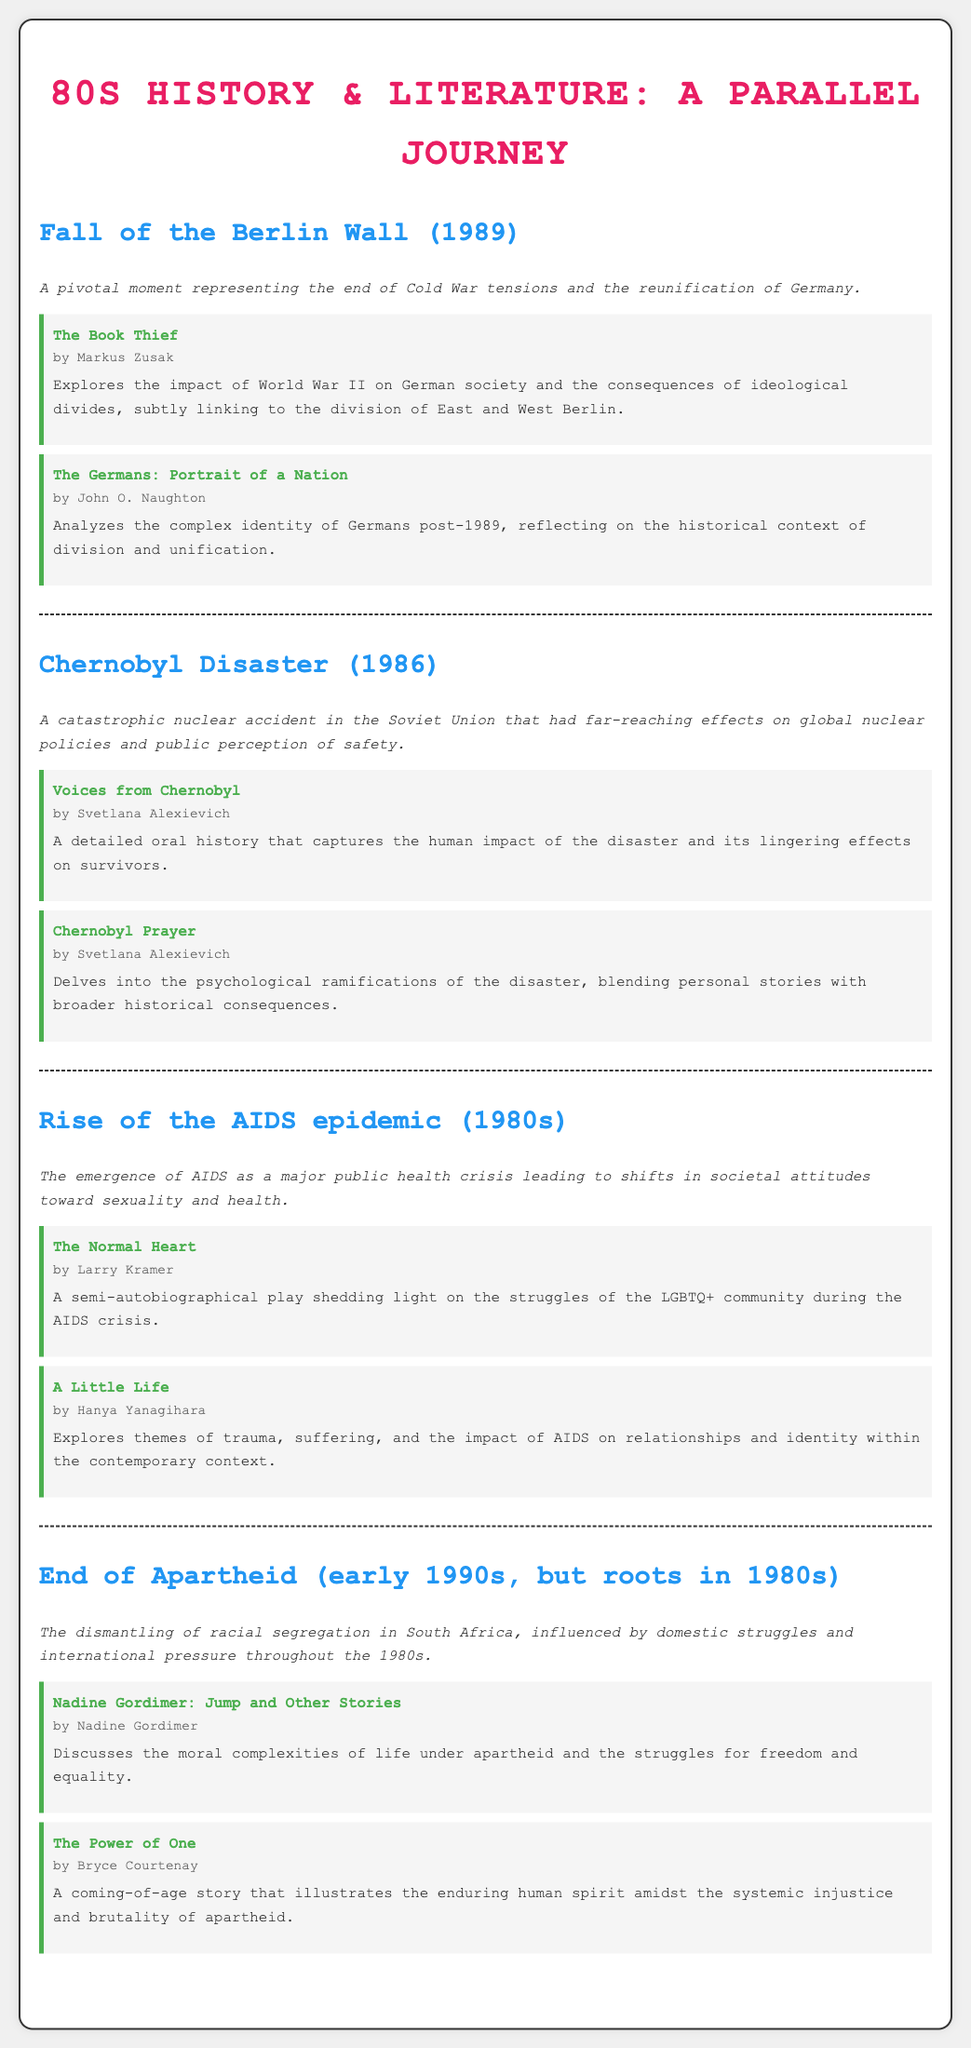What major event does the document focus on from 1989? The document highlights significant historical events of the 1980s, including the Fall of the Berlin Wall in 1989.
Answer: Fall of the Berlin Wall Who is the author of "The Normal Heart"? The document mentions the author of the play "The Normal Heart" in the context of the AIDS epidemic.
Answer: Larry Kramer What catastrophic event occurred in 1986? The document includes the Chernobyl Disaster, a significant event in the 1980s.
Answer: Chernobyl Disaster Which novel reflects on the human impact of the Chernobyl disaster? The document lists "Voices from Chernobyl" as an exploration of the disaster's effects on people.
Answer: Voices from Chernobyl What theme is explored in "A Little Life"? The novel "A Little Life" is described in relation to the impacts of AIDS on relationships and identity.
Answer: Trauma, suffering, and the impact of AIDS Which author wrote "The Power of One"? The document specifies the author of "The Power of One" in discussing apartheid.
Answer: Bryce Courtenay What significant societal issue rose to prominence in the 1980s according to the document? The document discusses the rise of the AIDS epidemic as a major public health crisis during the 1980s.
Answer: AIDS epidemic What literary work is associated with analyzing Germany's post-1989 identity? The document connects "The Germans: Portrait of a Nation" with themes of German identity post-1989.
Answer: The Germans: Portrait of a Nation 